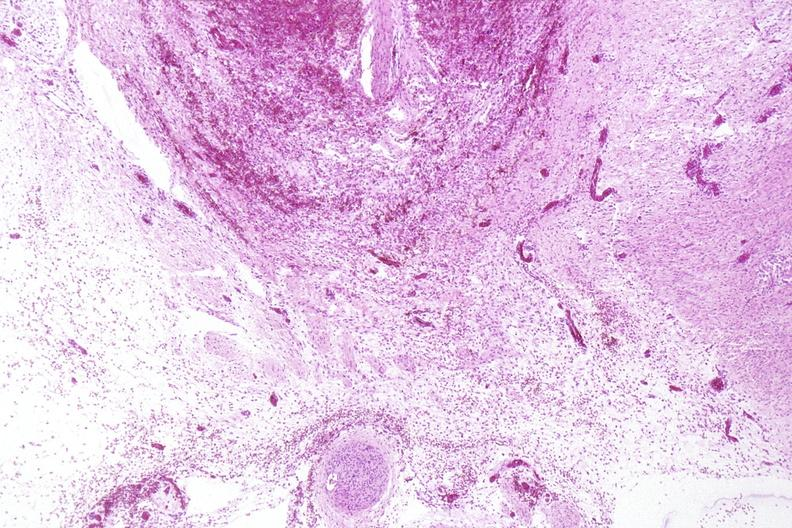where is this?
Answer the question using a single word or phrase. Nervous 